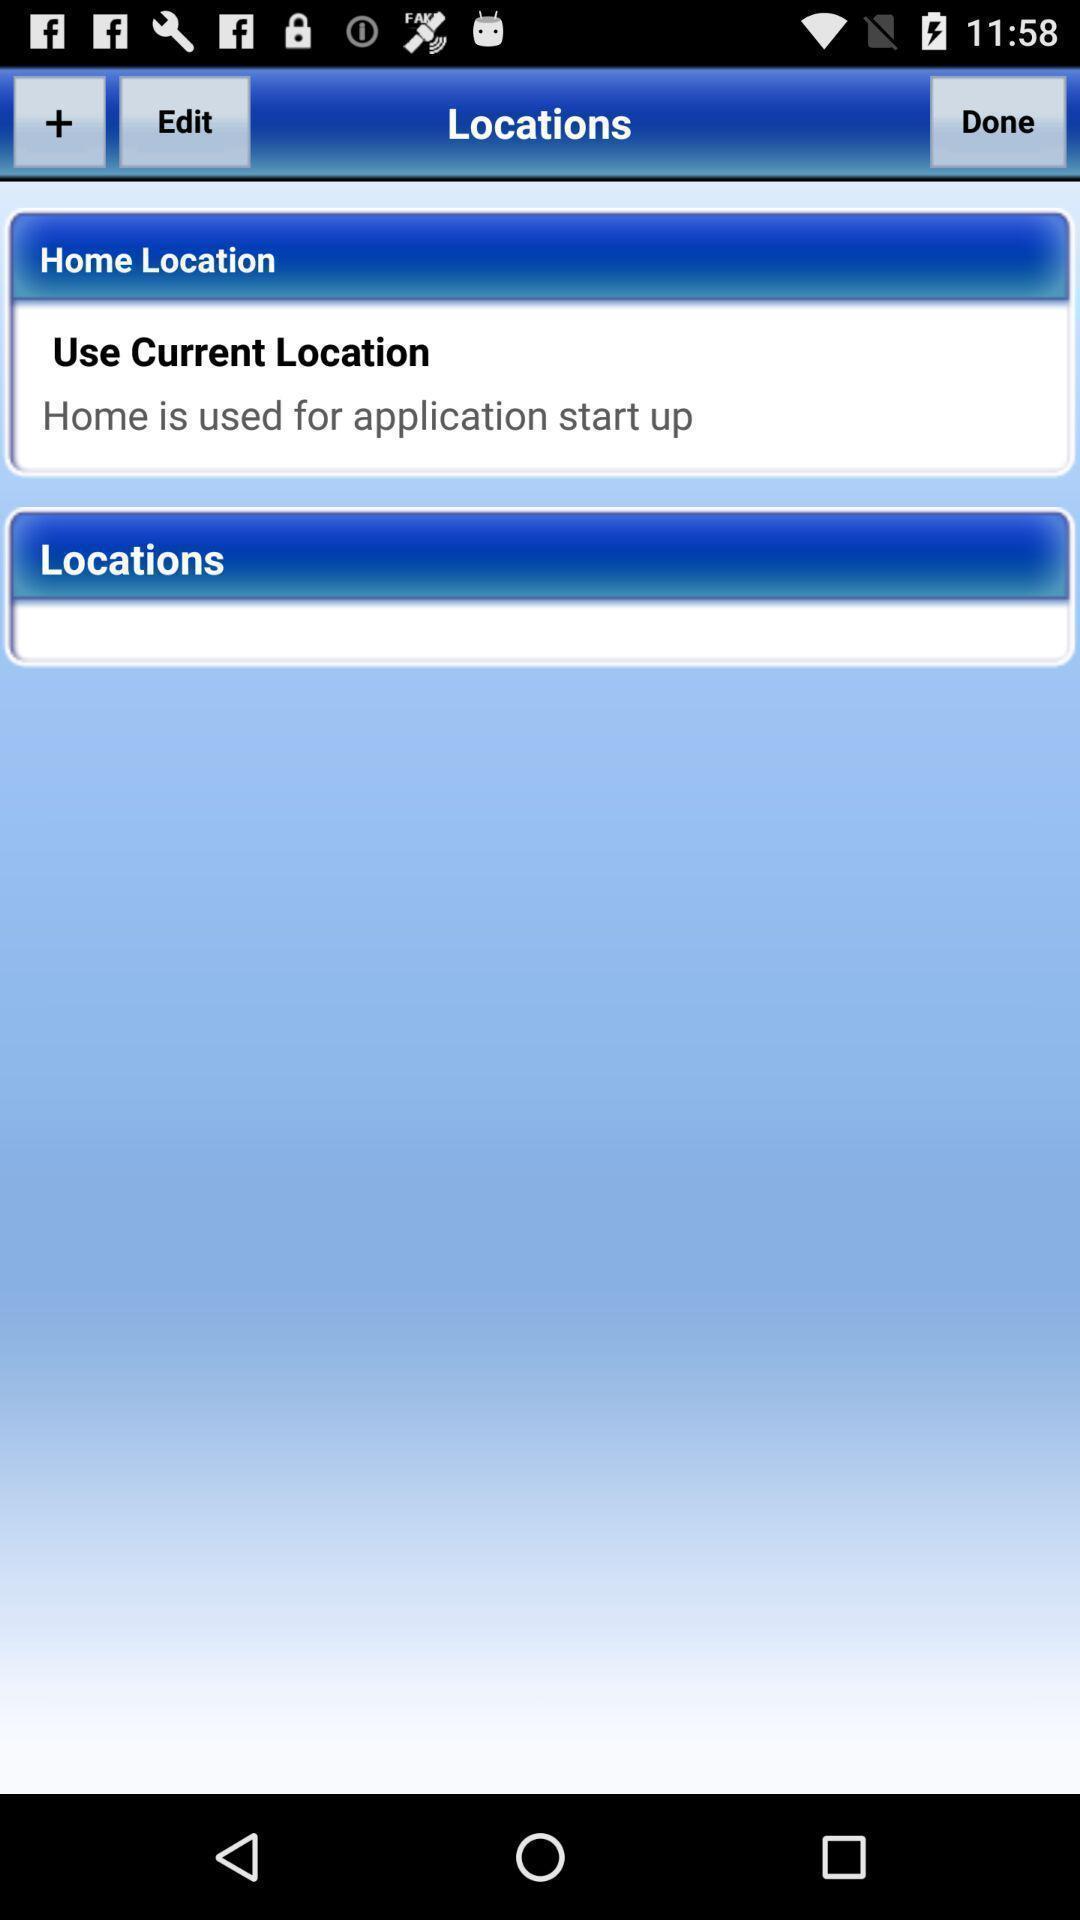Summarize the main components in this picture. Screen shows about home current locations. 